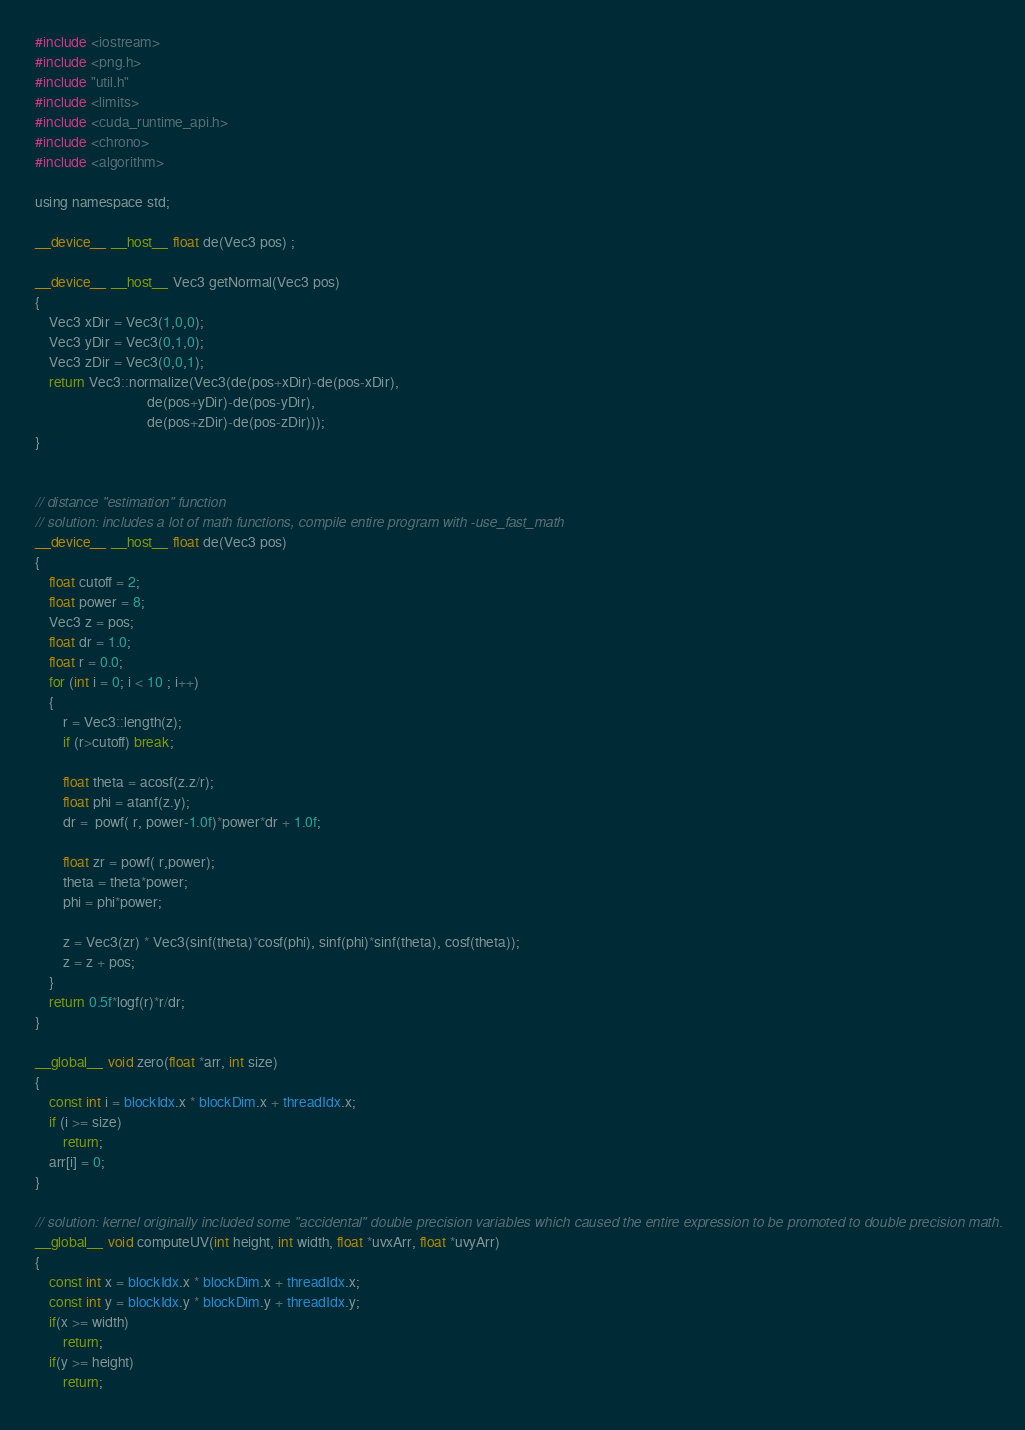<code> <loc_0><loc_0><loc_500><loc_500><_Cuda_>#include <iostream>
#include <png.h>
#include "util.h"
#include <limits>
#include <cuda_runtime_api.h>
#include <chrono>
#include <algorithm>

using namespace std;

__device__ __host__ float de(Vec3 pos) ;

__device__ __host__ Vec3 getNormal(Vec3 pos) 
{
	Vec3 xDir = Vec3(1,0,0);
	Vec3 yDir = Vec3(0,1,0);
	Vec3 zDir = Vec3(0,0,1);
	return Vec3::normalize(Vec3(de(pos+xDir)-de(pos-xDir),
	                            de(pos+yDir)-de(pos-yDir),
	                            de(pos+zDir)-de(pos-zDir)));
}


// distance "estimation" function 
// solution: includes a lot of math functions, compile entire program with -use_fast_math
__device__ __host__ float de(Vec3 pos) 
{
    float cutoff = 2;
    float power = 8;
	Vec3 z = pos;
	float dr = 1.0;
	float r = 0.0;
	for (int i = 0; i < 10 ; i++) 
    {
		r = Vec3::length(z);
		if (r>cutoff) break;
		
		float theta = acosf(z.z/r);
		float phi = atanf(z.y);
		dr =  powf( r, power-1.0f)*power*dr + 1.0f;
		
		float zr = powf( r,power);
		theta = theta*power;
		phi = phi*power;
		
		z = Vec3(zr) * Vec3(sinf(theta)*cosf(phi), sinf(phi)*sinf(theta), cosf(theta));
		z = z + pos;
	}
	return 0.5f*logf(r)*r/dr;
}

__global__ void zero(float *arr, int size)
{
    const int i = blockIdx.x * blockDim.x + threadIdx.x;
    if (i >= size)
        return;
    arr[i] = 0;
}

// solution: kernel originally included some "accidental" double precision variables which caused the entire expression to be promoted to double precision math.
__global__ void computeUV(int height, int width, float *uvxArr, float *uvyArr)
{
    const int x = blockIdx.x * blockDim.x + threadIdx.x;
    const int y = blockIdx.y * blockDim.y + threadIdx.y;
    if(x >= width)
        return;
    if(y >= height)
        return;
</code> 